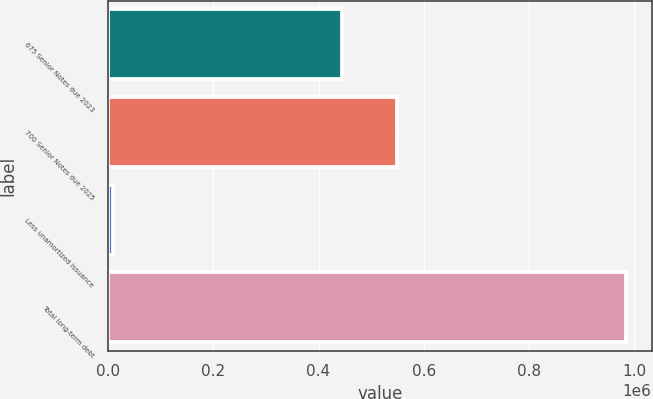<chart> <loc_0><loc_0><loc_500><loc_500><bar_chart><fcel>675 Senior Notes due 2023<fcel>700 Senior Notes due 2025<fcel>Less unamortized issuance<fcel>Total long-term debt<nl><fcel>444464<fcel>548500<fcel>9674<fcel>983290<nl></chart> 